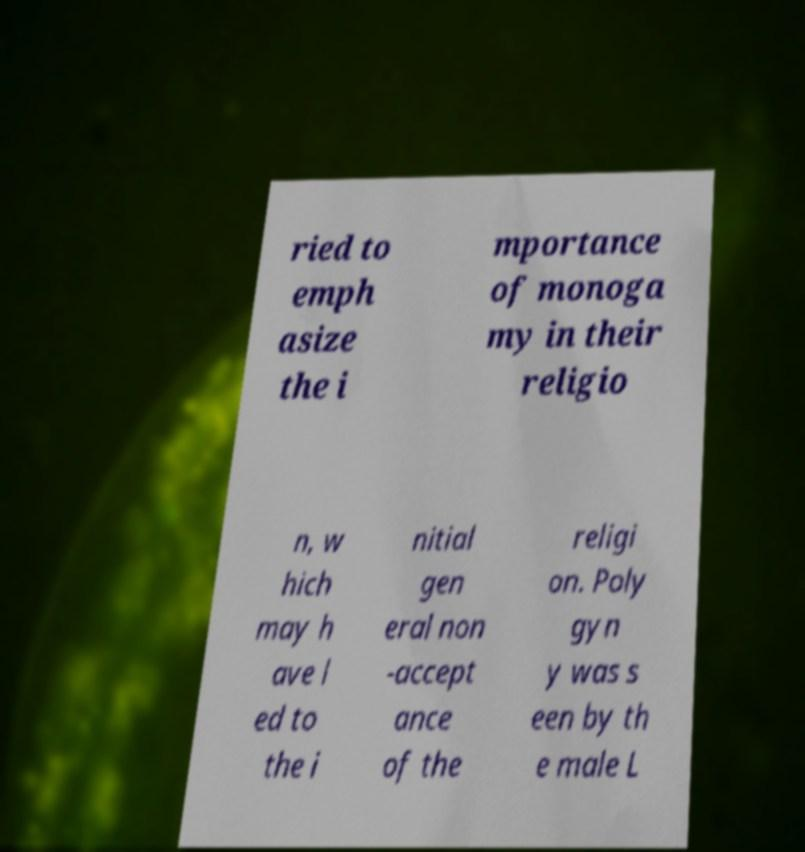Could you assist in decoding the text presented in this image and type it out clearly? ried to emph asize the i mportance of monoga my in their religio n, w hich may h ave l ed to the i nitial gen eral non -accept ance of the religi on. Poly gyn y was s een by th e male L 